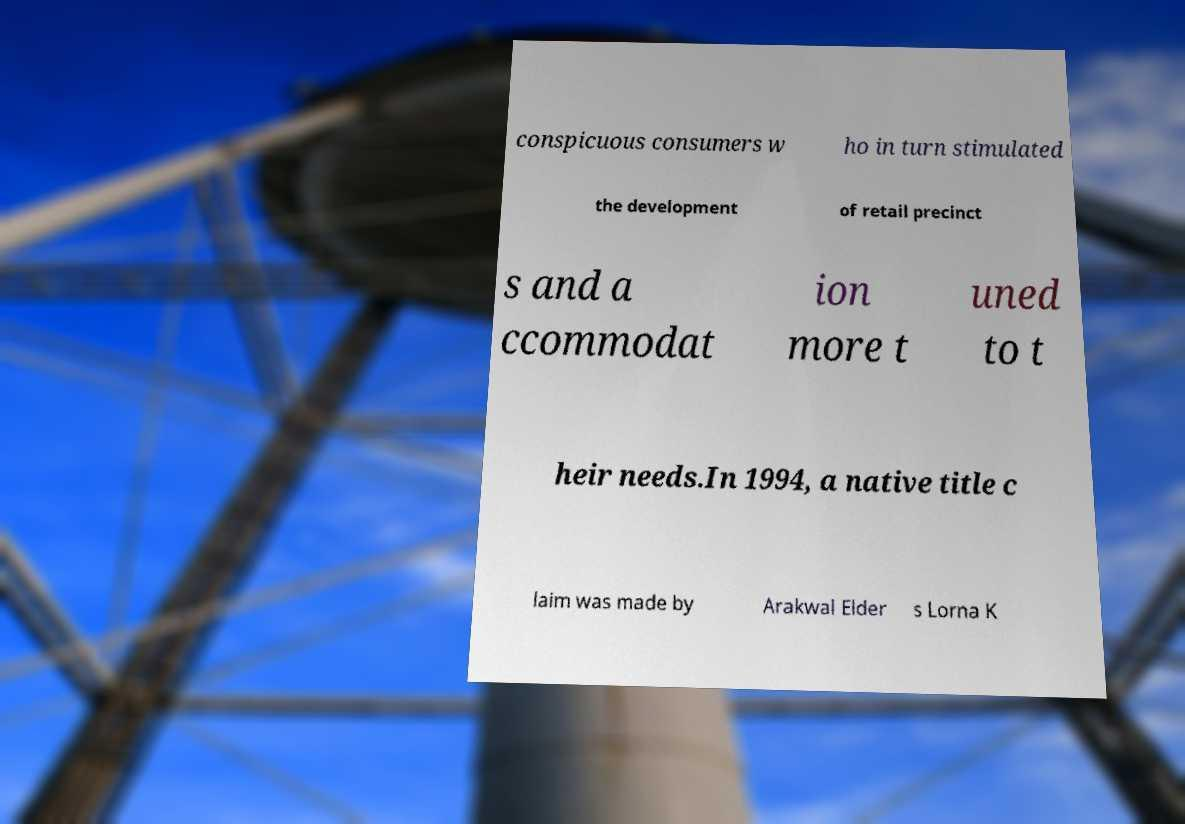For documentation purposes, I need the text within this image transcribed. Could you provide that? conspicuous consumers w ho in turn stimulated the development of retail precinct s and a ccommodat ion more t uned to t heir needs.In 1994, a native title c laim was made by Arakwal Elder s Lorna K 